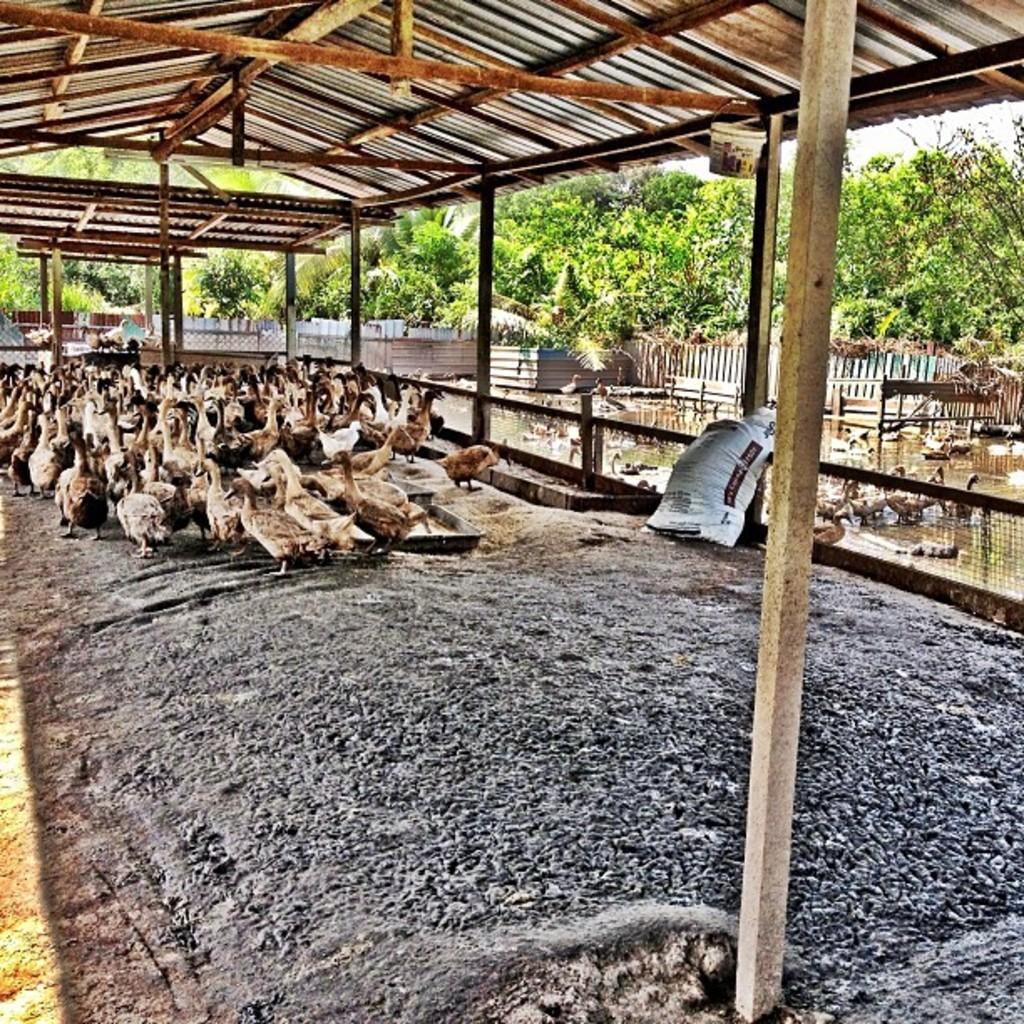Where are the birds located in the image? There are birds under the roof and visible on the side of the image. What else can be seen in the image besides the birds? There are trees in the image. What type of fruit is being used to press the button in the image? There is no fruit or button present in the image; it features birds and trees. 